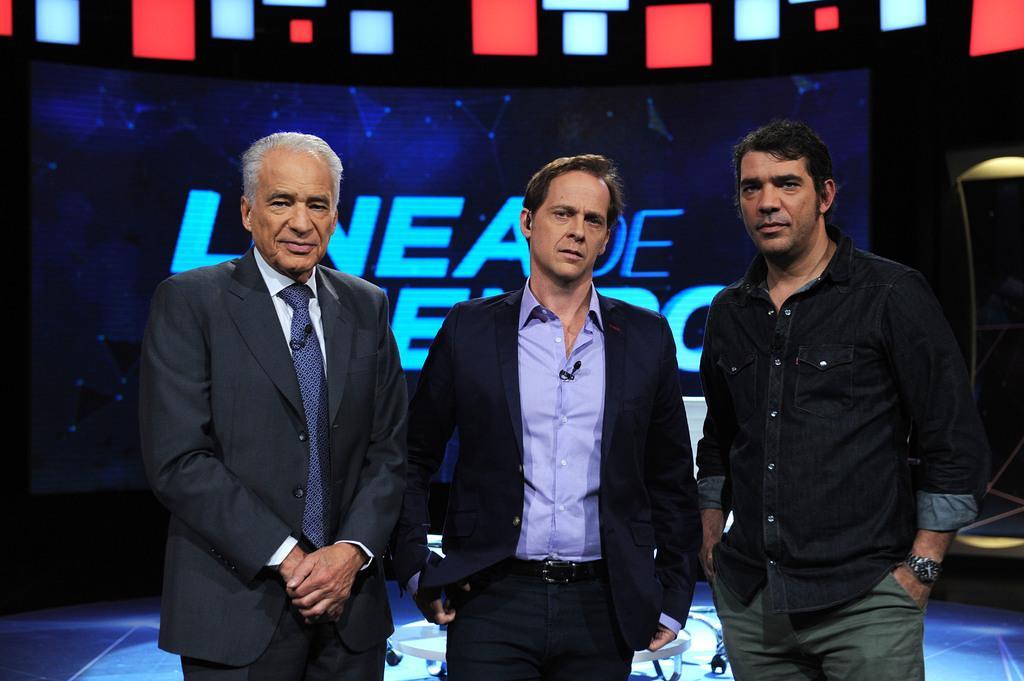Can you describe this image briefly? This image is taken indoors. In the background there is a screen with a text on it and there is a table on the floor. At the bottom of the image there is a floor. In the middle of the image three men are standing on the floor. 